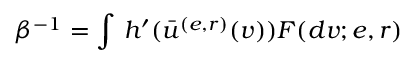Convert formula to latex. <formula><loc_0><loc_0><loc_500><loc_500>\beta ^ { - 1 } = \int \, h ^ { \prime } ( \bar { u } ^ { ( e , r ) } ( v ) ) F ( d v ; e , r )</formula> 